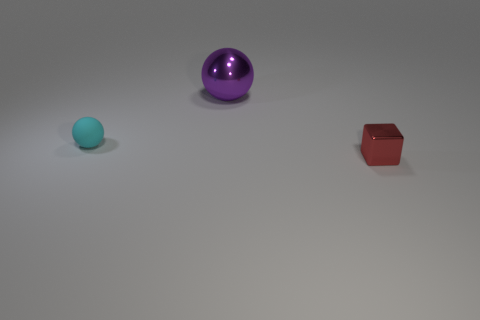There is a cyan thing that is the same size as the cube; what shape is it?
Give a very brief answer. Sphere. How many small objects are to the right of the ball in front of the large metallic thing?
Offer a terse response. 1. How many other objects are the same material as the red thing?
Give a very brief answer. 1. What shape is the metallic thing that is left of the shiny thing that is in front of the purple object?
Provide a short and direct response. Sphere. What size is the shiny thing that is behind the small cube?
Offer a very short reply. Large. Do the tiny sphere and the red cube have the same material?
Your answer should be compact. No. What shape is the large purple object that is the same material as the red cube?
Provide a short and direct response. Sphere. Is there any other thing that has the same color as the tiny metal cube?
Provide a short and direct response. No. What is the color of the thing behind the matte ball?
Your answer should be compact. Purple. There is a purple object that is the same shape as the tiny cyan rubber thing; what is it made of?
Your response must be concise. Metal. 